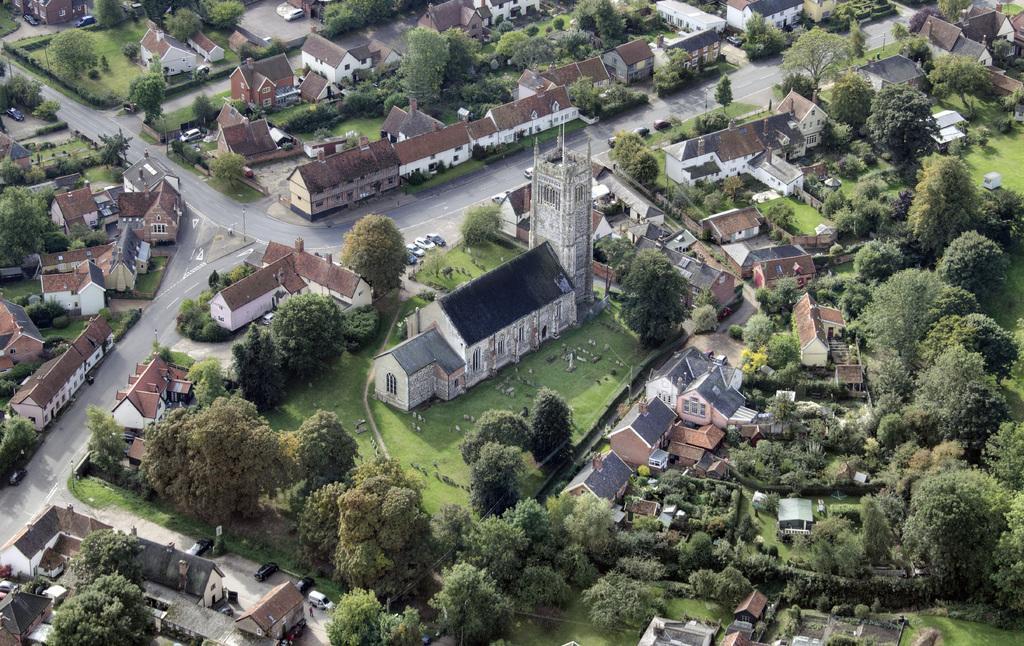Describe this image in one or two sentences. In this image there are buildings, trees and cars on the road. There is grass on the surface. 